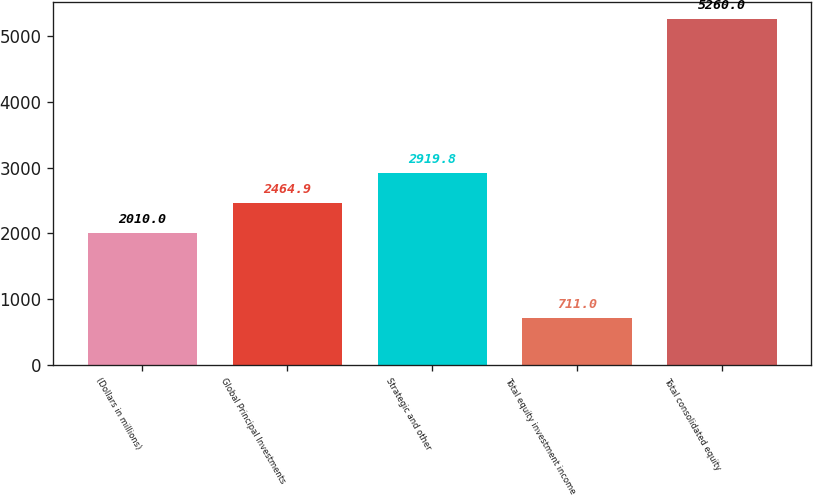Convert chart to OTSL. <chart><loc_0><loc_0><loc_500><loc_500><bar_chart><fcel>(Dollars in millions)<fcel>Global Principal Investments<fcel>Strategic and other<fcel>Total equity investment income<fcel>Total consolidated equity<nl><fcel>2010<fcel>2464.9<fcel>2919.8<fcel>711<fcel>5260<nl></chart> 